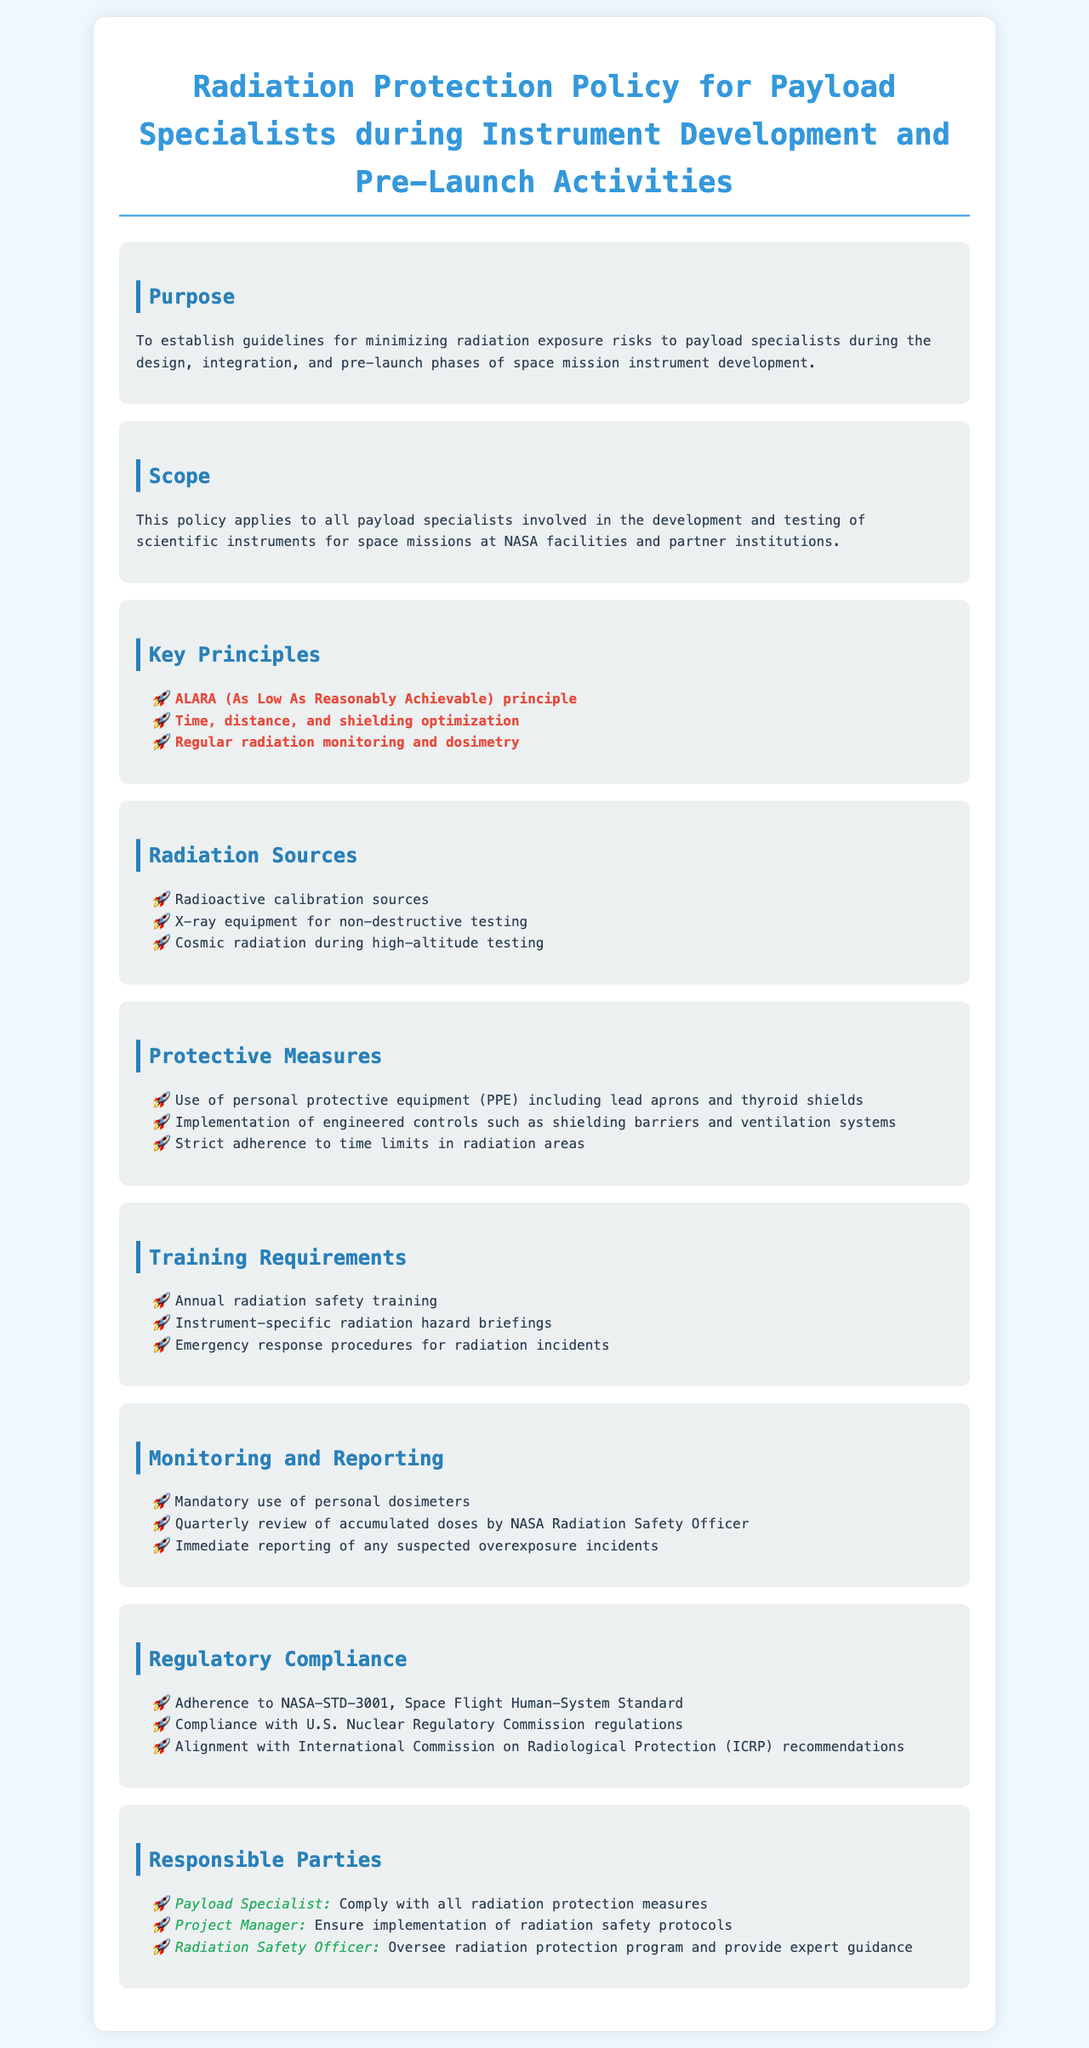What is the purpose of the policy? The purpose of the policy is to establish guidelines for minimizing radiation exposure risks to payload specialists during the design, integration, and pre-launch phases of space mission instrument development.
Answer: To establish guidelines for minimizing radiation exposure risks What is the key principle mentioned for radiation protection? The key principles listed in the document include "ALARA (As Low As Reasonably Achievable) principle."
Answer: ALARA (As Low As Reasonably Achievable) principle What are the protective measures recommended? Protective measures include "Use of personal protective equipment (PPE) including lead aprons and thyroid shields."
Answer: Use of personal protective equipment (PPE) including lead aprons and thyroid shields How often is radiation safety training required? The document states that "Annual radiation safety training" is a requirement.
Answer: Annual radiation safety training Who is responsible for overseeing the radiation protection program? The responsible party for overseeing the radiation protection program is the "Radiation Safety Officer."
Answer: Radiation Safety Officer What types of radiation sources are mentioned? The document lists "Radioactive calibration sources" as one of the radiation sources.
Answer: Radioactive calibration sources What must be reported immediately? The document specifies that "Immediate reporting of any suspected overexposure incidents" is necessary.
Answer: Immediate reporting of any suspected overexposure incidents What is the compliance standard mentioned? The compliance standard indicated is "NASA-STD-3001, Space Flight Human-System Standard."
Answer: NASA-STD-3001, Space Flight Human-System Standard 